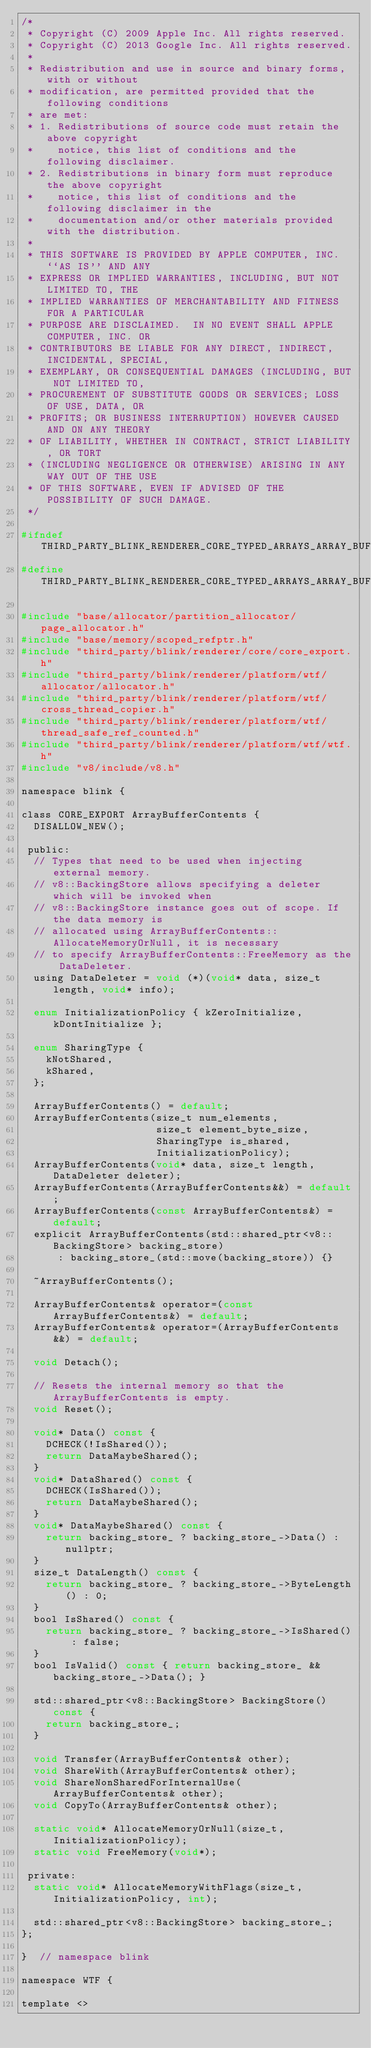Convert code to text. <code><loc_0><loc_0><loc_500><loc_500><_C_>/*
 * Copyright (C) 2009 Apple Inc. All rights reserved.
 * Copyright (C) 2013 Google Inc. All rights reserved.
 *
 * Redistribution and use in source and binary forms, with or without
 * modification, are permitted provided that the following conditions
 * are met:
 * 1. Redistributions of source code must retain the above copyright
 *    notice, this list of conditions and the following disclaimer.
 * 2. Redistributions in binary form must reproduce the above copyright
 *    notice, this list of conditions and the following disclaimer in the
 *    documentation and/or other materials provided with the distribution.
 *
 * THIS SOFTWARE IS PROVIDED BY APPLE COMPUTER, INC. ``AS IS'' AND ANY
 * EXPRESS OR IMPLIED WARRANTIES, INCLUDING, BUT NOT LIMITED TO, THE
 * IMPLIED WARRANTIES OF MERCHANTABILITY AND FITNESS FOR A PARTICULAR
 * PURPOSE ARE DISCLAIMED.  IN NO EVENT SHALL APPLE COMPUTER, INC. OR
 * CONTRIBUTORS BE LIABLE FOR ANY DIRECT, INDIRECT, INCIDENTAL, SPECIAL,
 * EXEMPLARY, OR CONSEQUENTIAL DAMAGES (INCLUDING, BUT NOT LIMITED TO,
 * PROCUREMENT OF SUBSTITUTE GOODS OR SERVICES; LOSS OF USE, DATA, OR
 * PROFITS; OR BUSINESS INTERRUPTION) HOWEVER CAUSED AND ON ANY THEORY
 * OF LIABILITY, WHETHER IN CONTRACT, STRICT LIABILITY, OR TORT
 * (INCLUDING NEGLIGENCE OR OTHERWISE) ARISING IN ANY WAY OUT OF THE USE
 * OF THIS SOFTWARE, EVEN IF ADVISED OF THE POSSIBILITY OF SUCH DAMAGE.
 */

#ifndef THIRD_PARTY_BLINK_RENDERER_CORE_TYPED_ARRAYS_ARRAY_BUFFER_ARRAY_BUFFER_CONTENTS_H_
#define THIRD_PARTY_BLINK_RENDERER_CORE_TYPED_ARRAYS_ARRAY_BUFFER_ARRAY_BUFFER_CONTENTS_H_

#include "base/allocator/partition_allocator/page_allocator.h"
#include "base/memory/scoped_refptr.h"
#include "third_party/blink/renderer/core/core_export.h"
#include "third_party/blink/renderer/platform/wtf/allocator/allocator.h"
#include "third_party/blink/renderer/platform/wtf/cross_thread_copier.h"
#include "third_party/blink/renderer/platform/wtf/thread_safe_ref_counted.h"
#include "third_party/blink/renderer/platform/wtf/wtf.h"
#include "v8/include/v8.h"

namespace blink {

class CORE_EXPORT ArrayBufferContents {
  DISALLOW_NEW();

 public:
  // Types that need to be used when injecting external memory.
  // v8::BackingStore allows specifying a deleter which will be invoked when
  // v8::BackingStore instance goes out of scope. If the data memory is
  // allocated using ArrayBufferContents::AllocateMemoryOrNull, it is necessary
  // to specify ArrayBufferContents::FreeMemory as the DataDeleter.
  using DataDeleter = void (*)(void* data, size_t length, void* info);

  enum InitializationPolicy { kZeroInitialize, kDontInitialize };

  enum SharingType {
    kNotShared,
    kShared,
  };

  ArrayBufferContents() = default;
  ArrayBufferContents(size_t num_elements,
                      size_t element_byte_size,
                      SharingType is_shared,
                      InitializationPolicy);
  ArrayBufferContents(void* data, size_t length, DataDeleter deleter);
  ArrayBufferContents(ArrayBufferContents&&) = default;
  ArrayBufferContents(const ArrayBufferContents&) = default;
  explicit ArrayBufferContents(std::shared_ptr<v8::BackingStore> backing_store)
      : backing_store_(std::move(backing_store)) {}

  ~ArrayBufferContents();

  ArrayBufferContents& operator=(const ArrayBufferContents&) = default;
  ArrayBufferContents& operator=(ArrayBufferContents&&) = default;

  void Detach();

  // Resets the internal memory so that the ArrayBufferContents is empty.
  void Reset();

  void* Data() const {
    DCHECK(!IsShared());
    return DataMaybeShared();
  }
  void* DataShared() const {
    DCHECK(IsShared());
    return DataMaybeShared();
  }
  void* DataMaybeShared() const {
    return backing_store_ ? backing_store_->Data() : nullptr;
  }
  size_t DataLength() const {
    return backing_store_ ? backing_store_->ByteLength() : 0;
  }
  bool IsShared() const {
    return backing_store_ ? backing_store_->IsShared() : false;
  }
  bool IsValid() const { return backing_store_ && backing_store_->Data(); }

  std::shared_ptr<v8::BackingStore> BackingStore() const {
    return backing_store_;
  }

  void Transfer(ArrayBufferContents& other);
  void ShareWith(ArrayBufferContents& other);
  void ShareNonSharedForInternalUse(ArrayBufferContents& other);
  void CopyTo(ArrayBufferContents& other);

  static void* AllocateMemoryOrNull(size_t, InitializationPolicy);
  static void FreeMemory(void*);

 private:
  static void* AllocateMemoryWithFlags(size_t, InitializationPolicy, int);

  std::shared_ptr<v8::BackingStore> backing_store_;
};

}  // namespace blink

namespace WTF {

template <></code> 